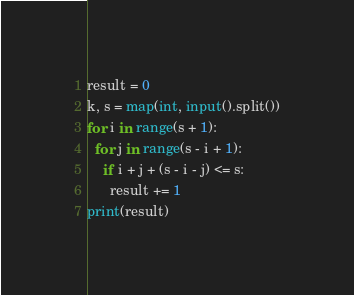Convert code to text. <code><loc_0><loc_0><loc_500><loc_500><_Python_>result = 0
k, s = map(int, input().split())
for i in range(s + 1):
  for j in range(s - i + 1):
    if i + j + (s - i - j) <= s:
      result += 1
print(result)</code> 